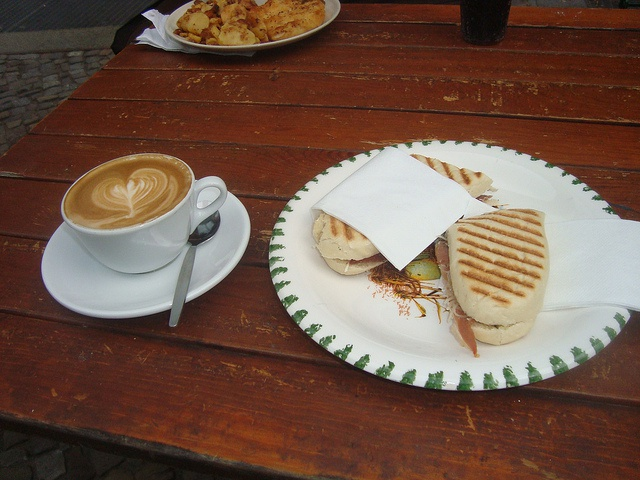Describe the objects in this image and their specific colors. I can see dining table in maroon, black, and brown tones, sandwich in black, tan, and brown tones, cup in black, darkgray, olive, and tan tones, sandwich in black, olive, maroon, and gray tones, and spoon in black, gray, and darkgray tones in this image. 